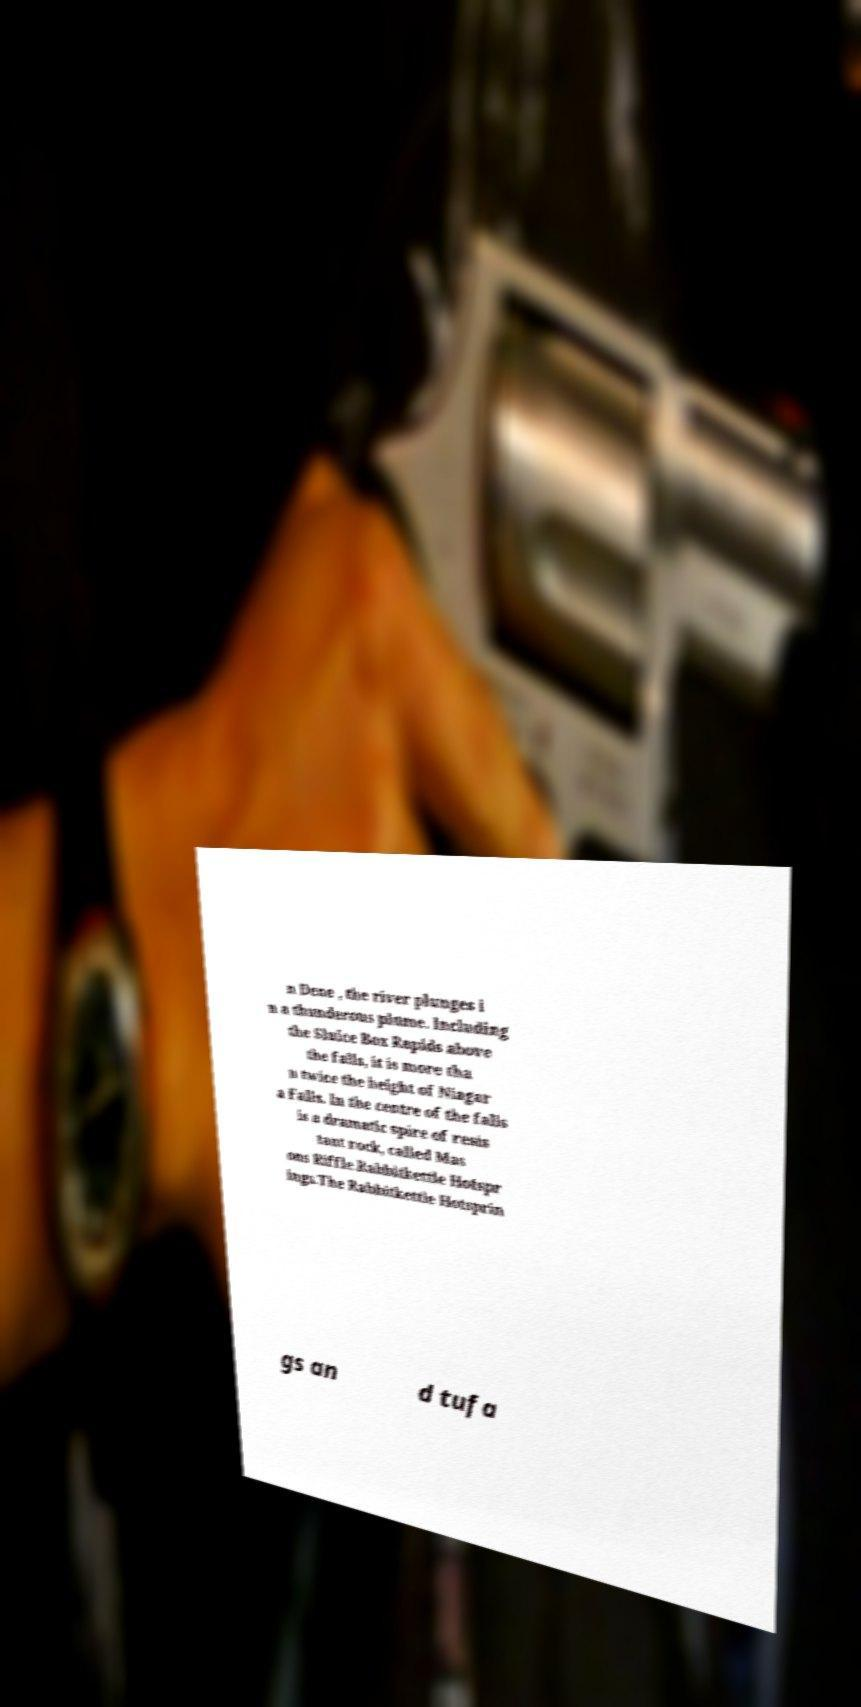I need the written content from this picture converted into text. Can you do that? n Dene , the river plunges i n a thunderous plume. Including the Sluice Box Rapids above the falls, it is more tha n twice the height of Niagar a Falls. In the centre of the falls is a dramatic spire of resis tant rock, called Mas ons Riffle.Rabbitkettle Hotspr ings.The Rabbitkettle Hotsprin gs an d tufa 